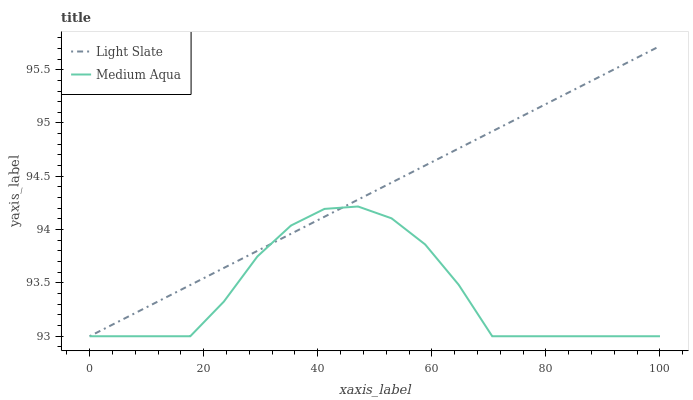Does Medium Aqua have the minimum area under the curve?
Answer yes or no. Yes. Does Light Slate have the maximum area under the curve?
Answer yes or no. Yes. Does Medium Aqua have the maximum area under the curve?
Answer yes or no. No. Is Light Slate the smoothest?
Answer yes or no. Yes. Is Medium Aqua the roughest?
Answer yes or no. Yes. Is Medium Aqua the smoothest?
Answer yes or no. No. Does Light Slate have the lowest value?
Answer yes or no. Yes. Does Light Slate have the highest value?
Answer yes or no. Yes. Does Medium Aqua have the highest value?
Answer yes or no. No. Does Medium Aqua intersect Light Slate?
Answer yes or no. Yes. Is Medium Aqua less than Light Slate?
Answer yes or no. No. Is Medium Aqua greater than Light Slate?
Answer yes or no. No. 